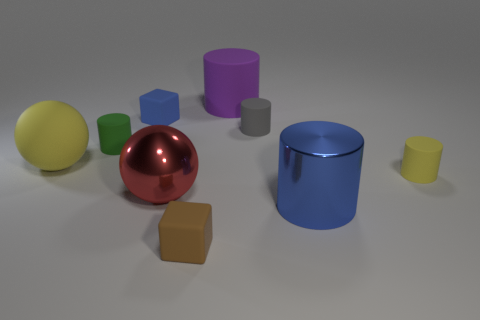Describe the lighting and shadows evident in the image. The image shows a soft and diffuse light source that creates gentle shadows on the ground beneath each object. The shadows are positioned mostly to the bottom-right of the objects, suggesting the light source is coming from the top-left. 